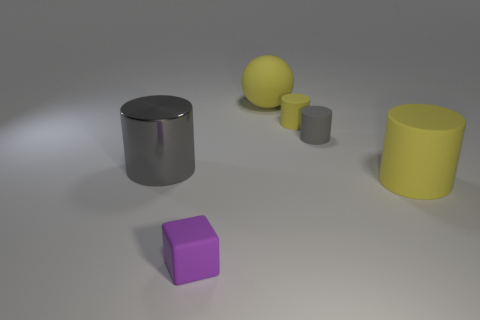Add 1 small yellow rubber cylinders. How many objects exist? 7 Subtract all blocks. How many objects are left? 5 Add 3 purple blocks. How many purple blocks exist? 4 Subtract 0 red cylinders. How many objects are left? 6 Subtract all large yellow objects. Subtract all tiny purple matte blocks. How many objects are left? 3 Add 1 small gray rubber cylinders. How many small gray rubber cylinders are left? 2 